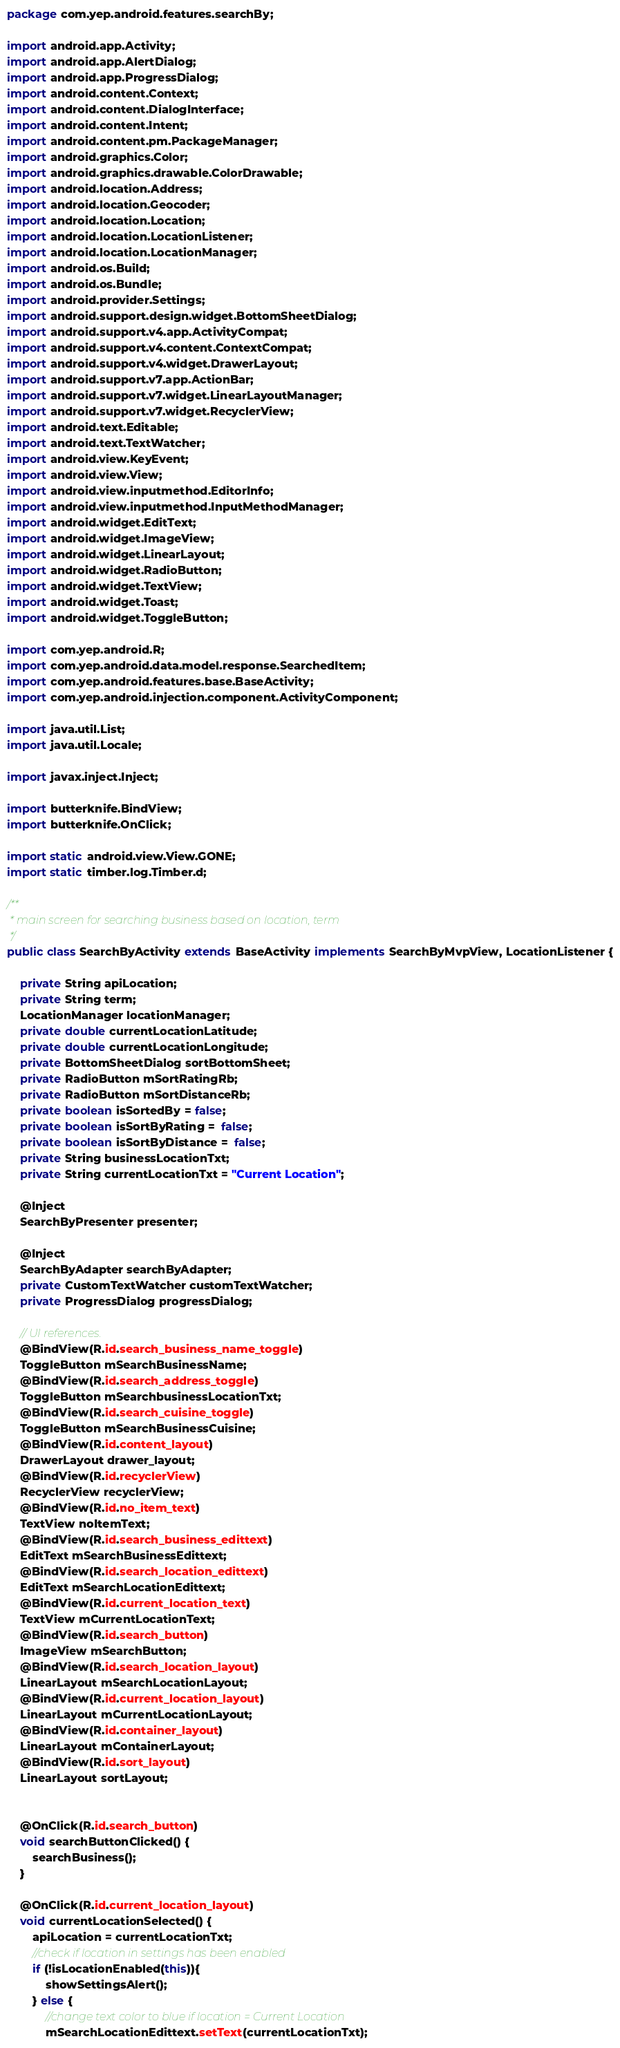Convert code to text. <code><loc_0><loc_0><loc_500><loc_500><_Java_>package com.yep.android.features.searchBy;

import android.app.Activity;
import android.app.AlertDialog;
import android.app.ProgressDialog;
import android.content.Context;
import android.content.DialogInterface;
import android.content.Intent;
import android.content.pm.PackageManager;
import android.graphics.Color;
import android.graphics.drawable.ColorDrawable;
import android.location.Address;
import android.location.Geocoder;
import android.location.Location;
import android.location.LocationListener;
import android.location.LocationManager;
import android.os.Build;
import android.os.Bundle;
import android.provider.Settings;
import android.support.design.widget.BottomSheetDialog;
import android.support.v4.app.ActivityCompat;
import android.support.v4.content.ContextCompat;
import android.support.v4.widget.DrawerLayout;
import android.support.v7.app.ActionBar;
import android.support.v7.widget.LinearLayoutManager;
import android.support.v7.widget.RecyclerView;
import android.text.Editable;
import android.text.TextWatcher;
import android.view.KeyEvent;
import android.view.View;
import android.view.inputmethod.EditorInfo;
import android.view.inputmethod.InputMethodManager;
import android.widget.EditText;
import android.widget.ImageView;
import android.widget.LinearLayout;
import android.widget.RadioButton;
import android.widget.TextView;
import android.widget.Toast;
import android.widget.ToggleButton;

import com.yep.android.R;
import com.yep.android.data.model.response.SearchedItem;
import com.yep.android.features.base.BaseActivity;
import com.yep.android.injection.component.ActivityComponent;

import java.util.List;
import java.util.Locale;

import javax.inject.Inject;

import butterknife.BindView;
import butterknife.OnClick;

import static android.view.View.GONE;
import static timber.log.Timber.d;

/**
 * main screen for searching business based on location, term
 */
public class SearchByActivity extends BaseActivity implements SearchByMvpView, LocationListener {

    private String apiLocation;
    private String term;
    LocationManager locationManager;
    private double currentLocationLatitude;
    private double currentLocationLongitude;
    private BottomSheetDialog sortBottomSheet;
    private RadioButton mSortRatingRb;
    private RadioButton mSortDistanceRb;
    private boolean isSortedBy = false;
    private boolean isSortByRating =  false;
    private boolean isSortByDistance =  false;
    private String businessLocationTxt;
    private String currentLocationTxt = "Current Location";

    @Inject
    SearchByPresenter presenter;

    @Inject
    SearchByAdapter searchByAdapter;
    private CustomTextWatcher customTextWatcher;
    private ProgressDialog progressDialog;

    // UI references.
    @BindView(R.id.search_business_name_toggle)
    ToggleButton mSearchBusinessName;
    @BindView(R.id.search_address_toggle)
    ToggleButton mSearchbusinessLocationTxt;
    @BindView(R.id.search_cuisine_toggle)
    ToggleButton mSearchBusinessCuisine;
    @BindView(R.id.content_layout)
    DrawerLayout drawer_layout;
    @BindView(R.id.recyclerView)
    RecyclerView recyclerView;
    @BindView(R.id.no_item_text)
    TextView noItemText;
    @BindView(R.id.search_business_edittext)
    EditText mSearchBusinessEdittext;
    @BindView(R.id.search_location_edittext)
    EditText mSearchLocationEdittext;
    @BindView(R.id.current_location_text)
    TextView mCurrentLocationText;
    @BindView(R.id.search_button)
    ImageView mSearchButton;
    @BindView(R.id.search_location_layout)
    LinearLayout mSearchLocationLayout;
    @BindView(R.id.current_location_layout)
    LinearLayout mCurrentLocationLayout;
    @BindView(R.id.container_layout)
    LinearLayout mContainerLayout;
    @BindView(R.id.sort_layout)
    LinearLayout sortLayout;


    @OnClick(R.id.search_button)
    void searchButtonClicked() {
        searchBusiness();
    }

    @OnClick(R.id.current_location_layout)
    void currentLocationSelected() {
        apiLocation = currentLocationTxt;
        //check if location in settings has been enabled
        if (!isLocationEnabled(this)){
            showSettingsAlert();
        } else {
            //change text color to blue if location = Current Location
            mSearchLocationEdittext.setText(currentLocationTxt);</code> 